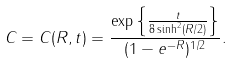<formula> <loc_0><loc_0><loc_500><loc_500>C = C ( R , t ) = \frac { \exp \left \{ \frac { t } { 8 \sinh ^ { 2 } ( R / 2 ) } \right \} } { ( 1 - e ^ { - R } ) ^ { 1 / 2 } } .</formula> 